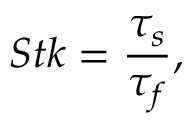<formula> <loc_0><loc_0><loc_500><loc_500>S t k = \frac { \tau _ { s } } { \tau _ { f } } ,</formula> 